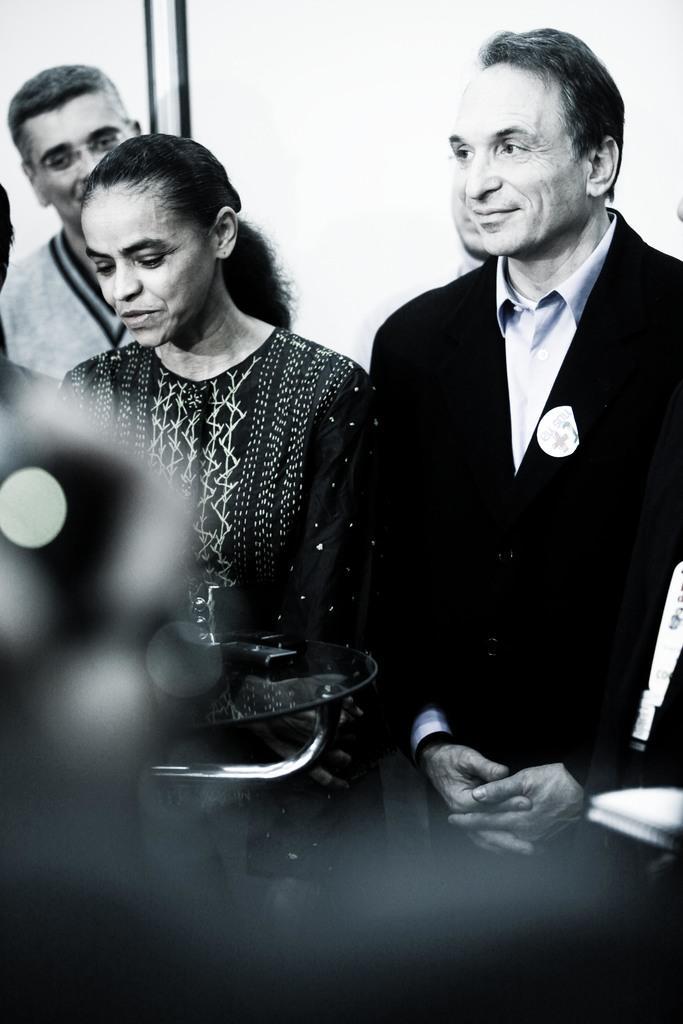Could you give a brief overview of what you see in this image? This is a black and white image. There are a few people. We can see a table with some objects. In the background, we can see the wall. 